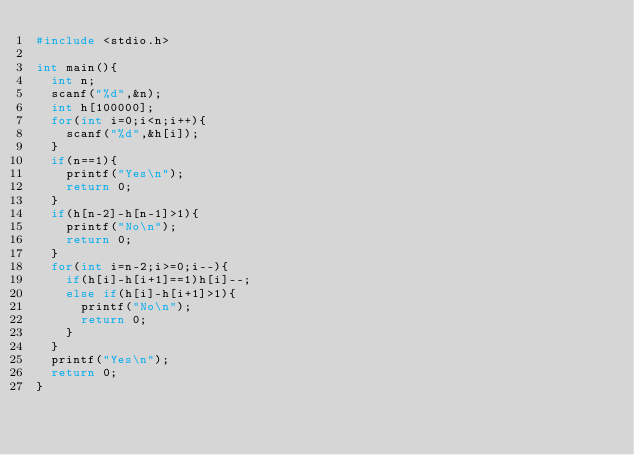Convert code to text. <code><loc_0><loc_0><loc_500><loc_500><_C_>#include <stdio.h>

int main(){
	int n;
	scanf("%d",&n);
	int h[100000];
	for(int i=0;i<n;i++){
		scanf("%d",&h[i]);
	}
	if(n==1){
		printf("Yes\n");
		return 0;
	}
	if(h[n-2]-h[n-1]>1){
		printf("No\n");
		return 0;
	}
	for(int i=n-2;i>=0;i--){
		if(h[i]-h[i+1]==1)h[i]--;
		else if(h[i]-h[i+1]>1){
			printf("No\n");
			return 0;
		}
	}
	printf("Yes\n");
	return 0;
}</code> 